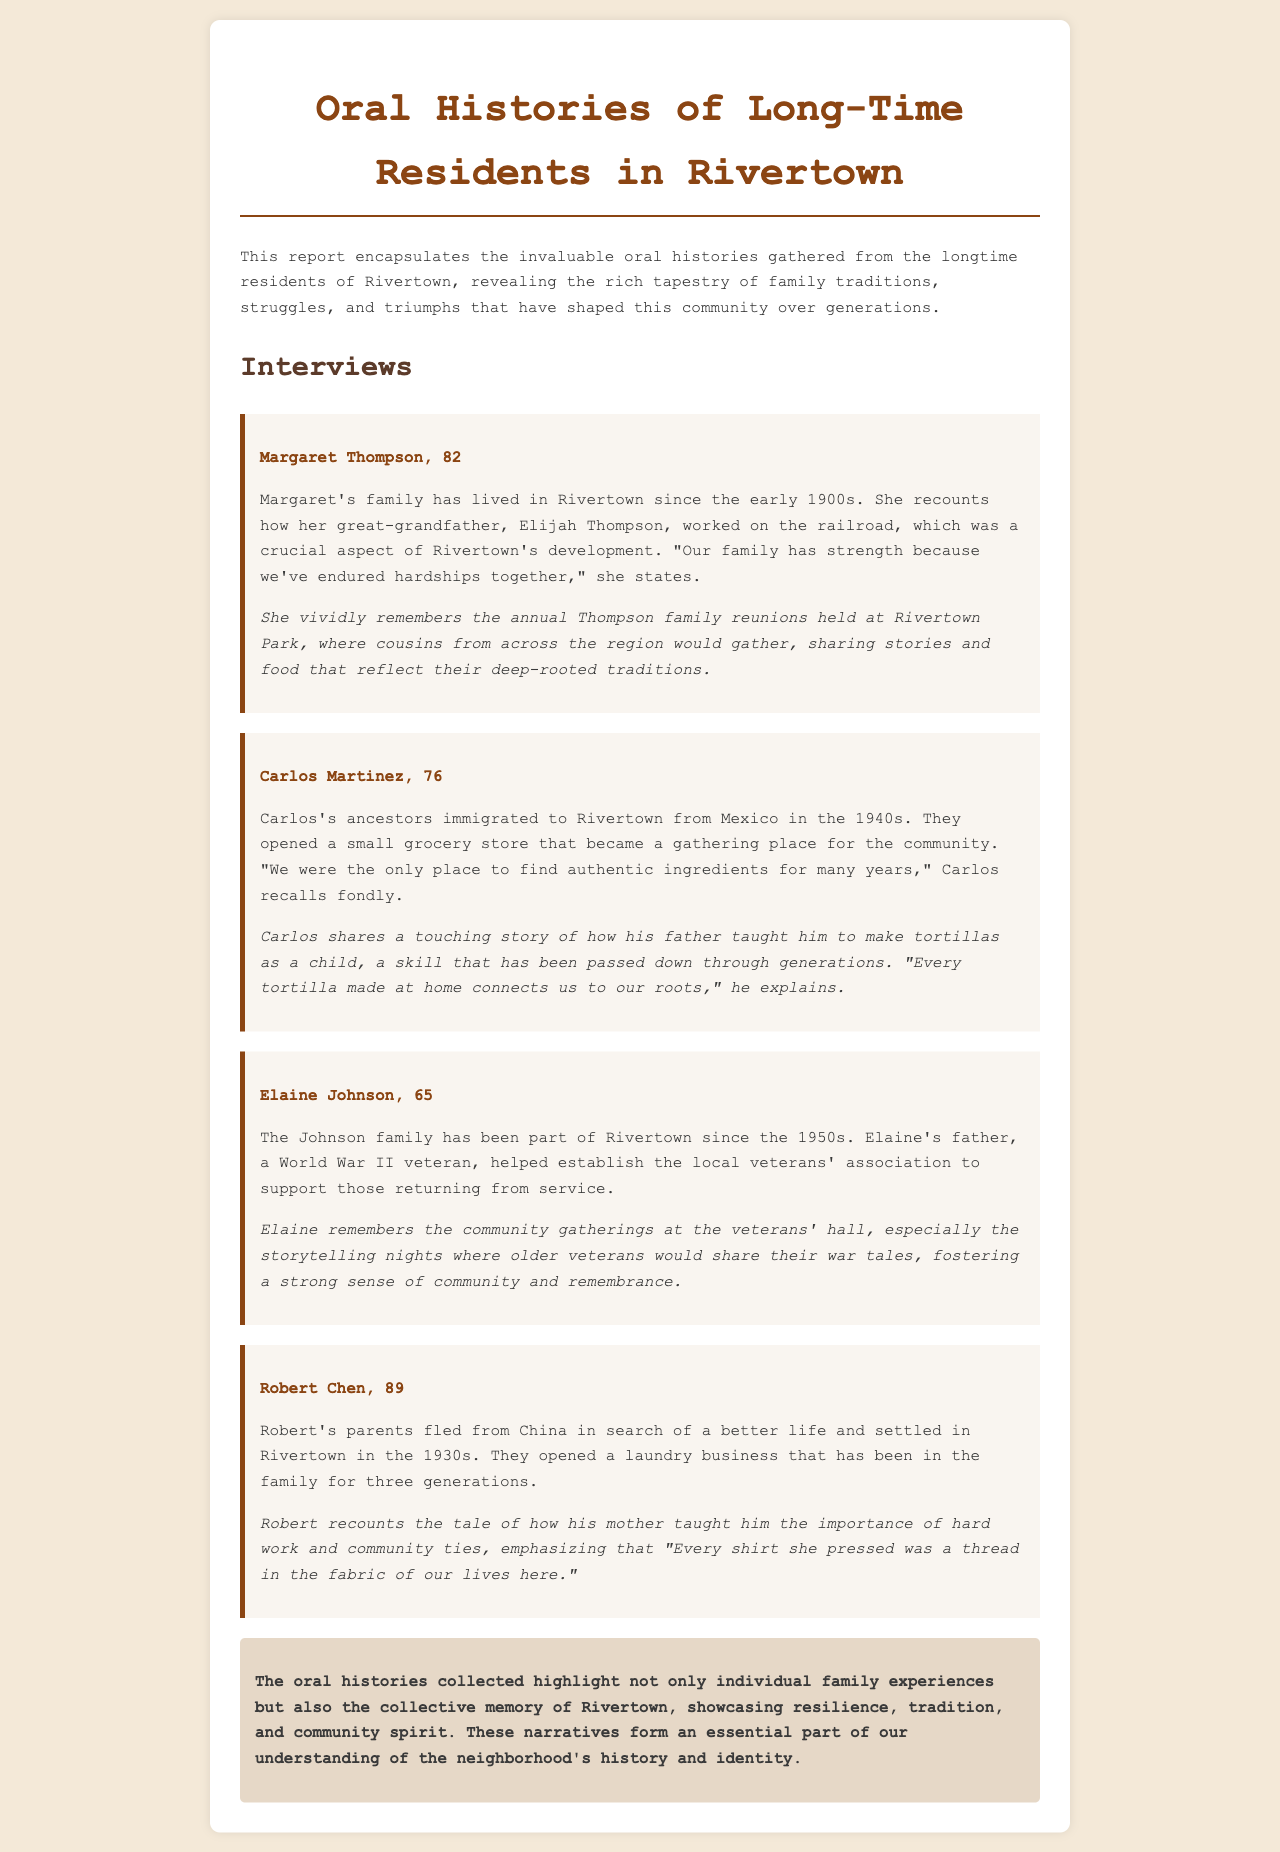What is the title of the report? The title of the report is prominently displayed at the beginning of the document as "Oral Histories of Long-Time Residents in Rivertown."
Answer: Oral Histories of Long-Time Residents in Rivertown Who is the oldest interviewee mentioned? The oldest interviewee mentioned is Robert Chen, who is 89 years old.
Answer: Robert Chen What year did Carlos's ancestors immigrate to Rivertown? The document states that Carlos's ancestors immigrated to Rivertown in the 1940s.
Answer: 1940s What profession was associated with Margaret Thompson's great-grandfather? Margaret Thompson's great-grandfather, Elijah Thompson, worked on the railroad, which was significant to Rivertown's development.
Answer: Railroad worker What community event does Margaret fondly remember? Margaret vividly remembers the annual Thompson family reunions held at Rivertown Park.
Answer: Annual Thompson family reunions What business did Robert Chen's parents open upon arriving in Rivertown? Robert Chen's parents opened a laundry business when they settled in Rivertown.
Answer: Laundry business How did Carlos connect his family heritage to his cooking? Carlos connects his family heritage to cooking by making tortillas, a skill taught by his father that connects him to their roots.
Answer: Making tortillas What specific night events does Elaine Johnson remember? Elaine Johnson remembers the storytelling nights at the veterans' hall where older veterans shared their experiences.
Answer: Storytelling nights 